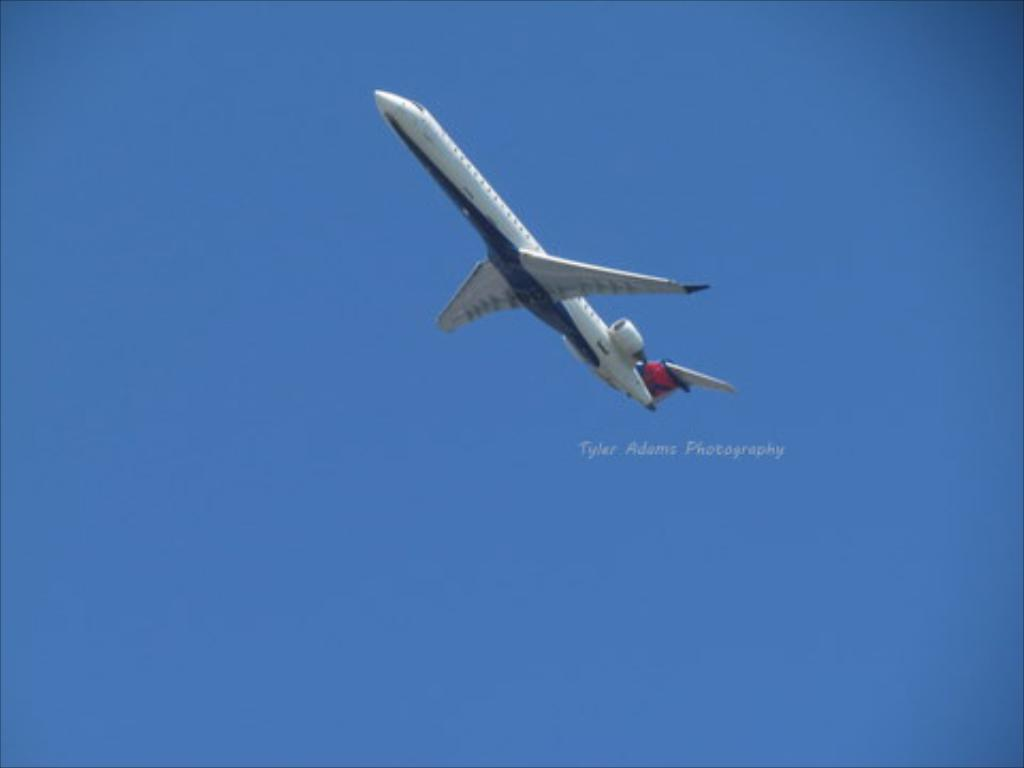What is the main subject of the image? The main subject of the image is an airplane flying. What can be seen in the background of the image? The sky is visible in the image. What is the color of the sky in the image? The sky is blue in color. Can you tell me where the comb is located in the image? There is no comb present in the image. What type of view can be seen from the airplane in the image? The image does not show a view from the airplane, as it is focused on the airplane itself. 